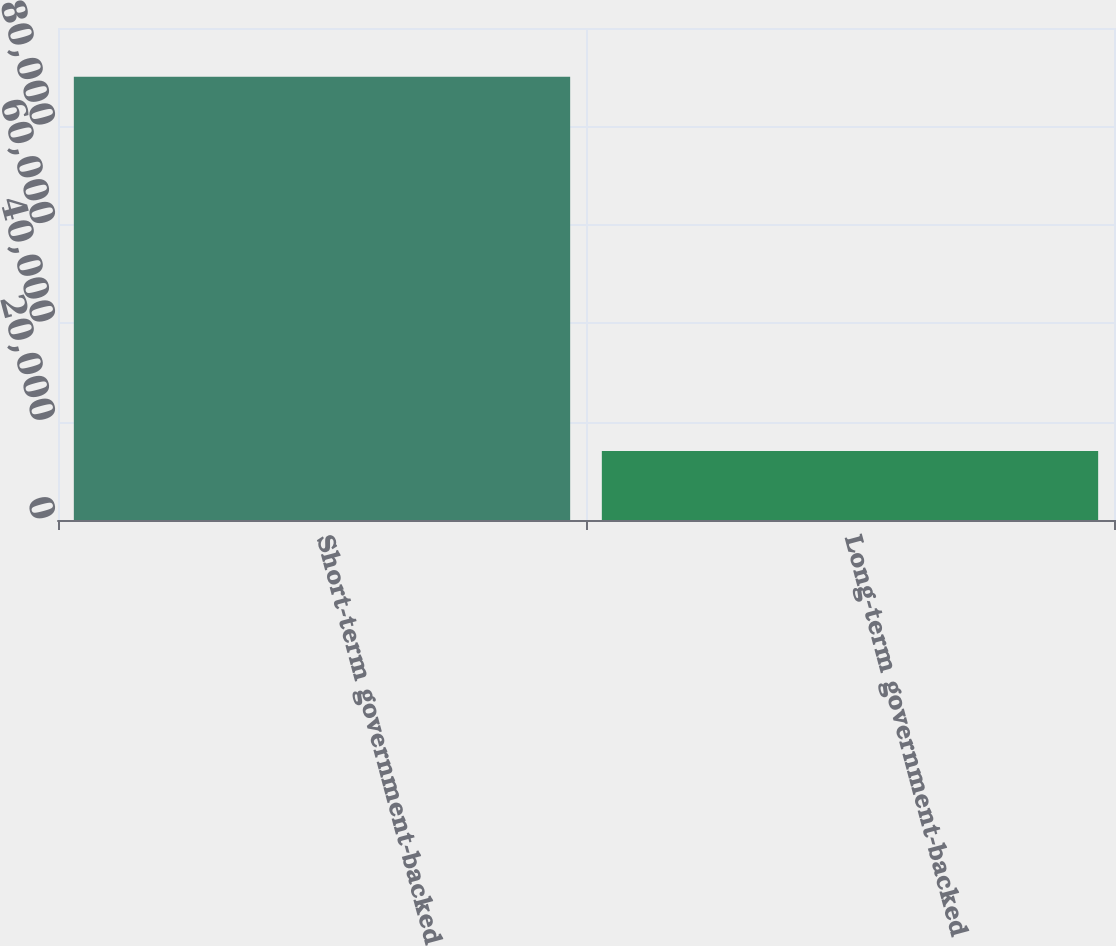Convert chart. <chart><loc_0><loc_0><loc_500><loc_500><bar_chart><fcel>Short-term government-backed<fcel>Long-term government-backed<nl><fcel>90070<fcel>13999<nl></chart> 